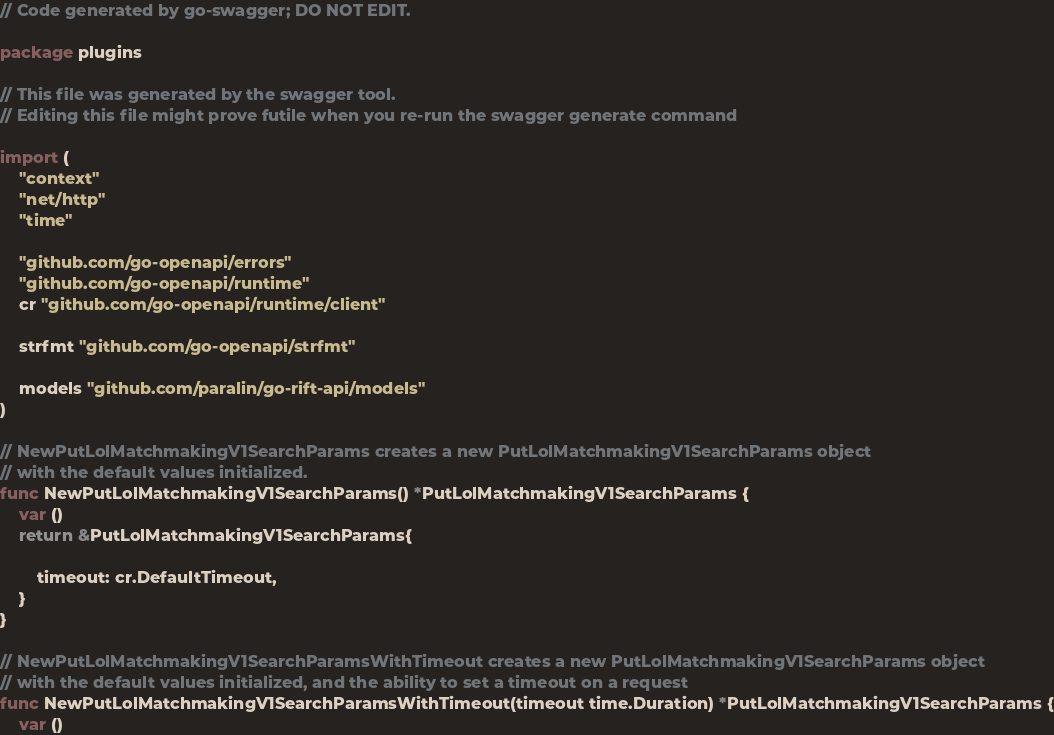<code> <loc_0><loc_0><loc_500><loc_500><_Go_>// Code generated by go-swagger; DO NOT EDIT.

package plugins

// This file was generated by the swagger tool.
// Editing this file might prove futile when you re-run the swagger generate command

import (
	"context"
	"net/http"
	"time"

	"github.com/go-openapi/errors"
	"github.com/go-openapi/runtime"
	cr "github.com/go-openapi/runtime/client"

	strfmt "github.com/go-openapi/strfmt"

	models "github.com/paralin/go-rift-api/models"
)

// NewPutLolMatchmakingV1SearchParams creates a new PutLolMatchmakingV1SearchParams object
// with the default values initialized.
func NewPutLolMatchmakingV1SearchParams() *PutLolMatchmakingV1SearchParams {
	var ()
	return &PutLolMatchmakingV1SearchParams{

		timeout: cr.DefaultTimeout,
	}
}

// NewPutLolMatchmakingV1SearchParamsWithTimeout creates a new PutLolMatchmakingV1SearchParams object
// with the default values initialized, and the ability to set a timeout on a request
func NewPutLolMatchmakingV1SearchParamsWithTimeout(timeout time.Duration) *PutLolMatchmakingV1SearchParams {
	var ()</code> 